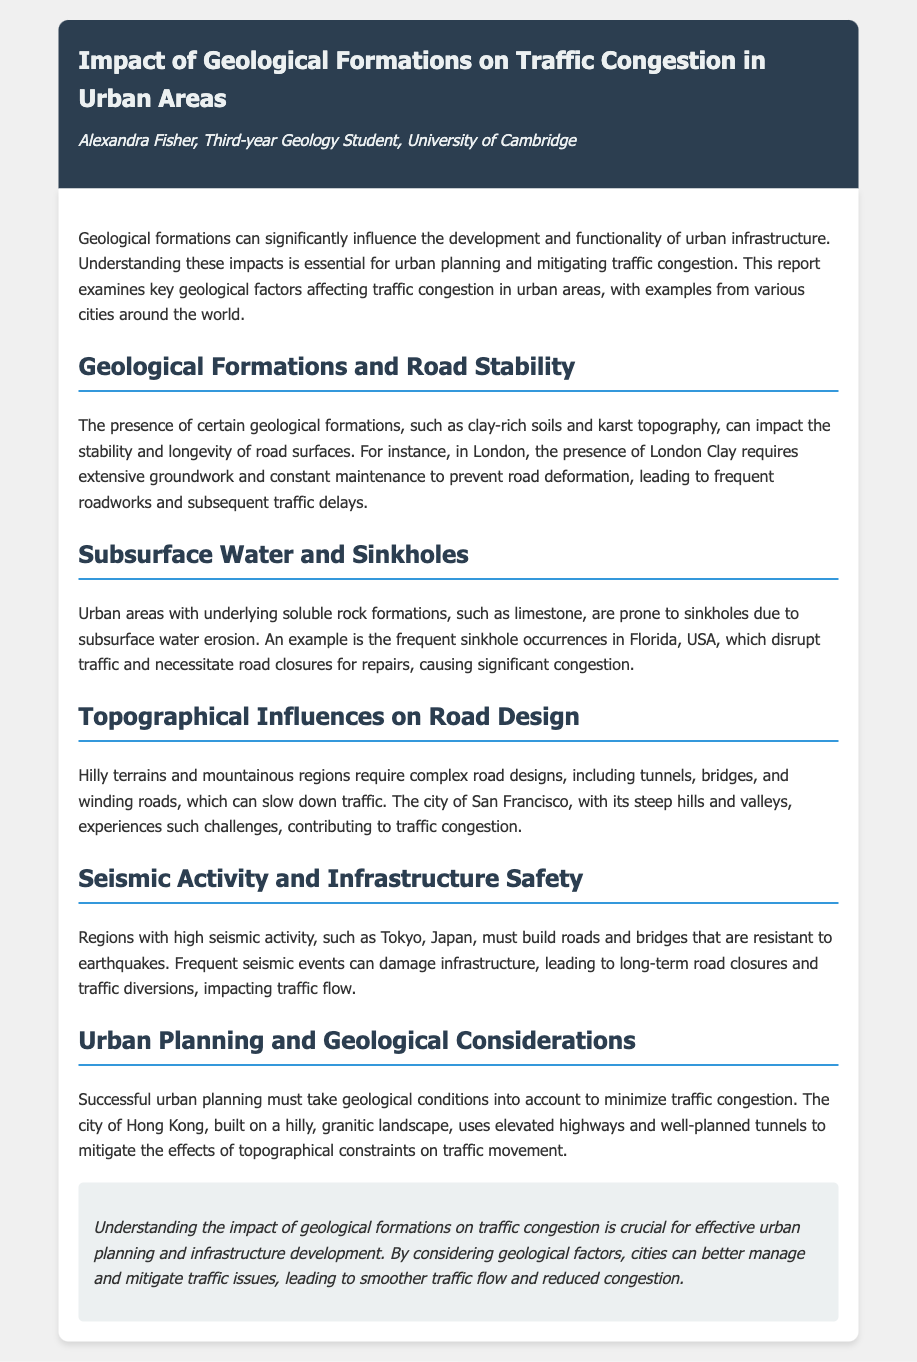What is the main topic of the report? The main topic to which the report is addressing involves the effects of geological formations on urban traffic congestion.
Answer: Impact of Geological Formations on Traffic Congestion in Urban Areas Who is the author of the report? The report lists Alexandra Fisher as the author in the header section.
Answer: Alexandra Fisher Which geological formation is mentioned as affecting road stability in London? The report specifically identifies London Clay as a geological formation that impacts road stability.
Answer: London Clay What problem do soluble rock formations like limestone cause in urban areas? The document highlights that soluble rock formations lead to sinkholes, which create disruptions in urban traffic.
Answer: Sinkholes What urban planning strategy is mentioned for managing traffic in Hong Kong? The report notes the use of elevated highways and well-planned tunnels to mitigate traffic congestion.
Answer: Elevated highways and tunnels What region is specifically identified as having high seismic activity? The document mentions Tokyo, Japan, in the context of high seismic activity affecting infrastructure.
Answer: Tokyo What is a significant traffic issue caused by topographical influences in San Francisco? The hilly terrain of San Francisco necessitates complex road designs, leading to slower traffic flow and congestion.
Answer: Slow traffic flow and congestion How can urban areas reduce traffic congestion according to the report? The report suggests that considering geological factors in urban planning can lead to better traffic management.
Answer: Considering geological factors What frequent event in Florida disrupts traffic, as discussed in the report? The occurrence of sinkholes, due to underlying soluble rock, is noted as a major traffic disruptor in Florida.
Answer: Sinkholes 